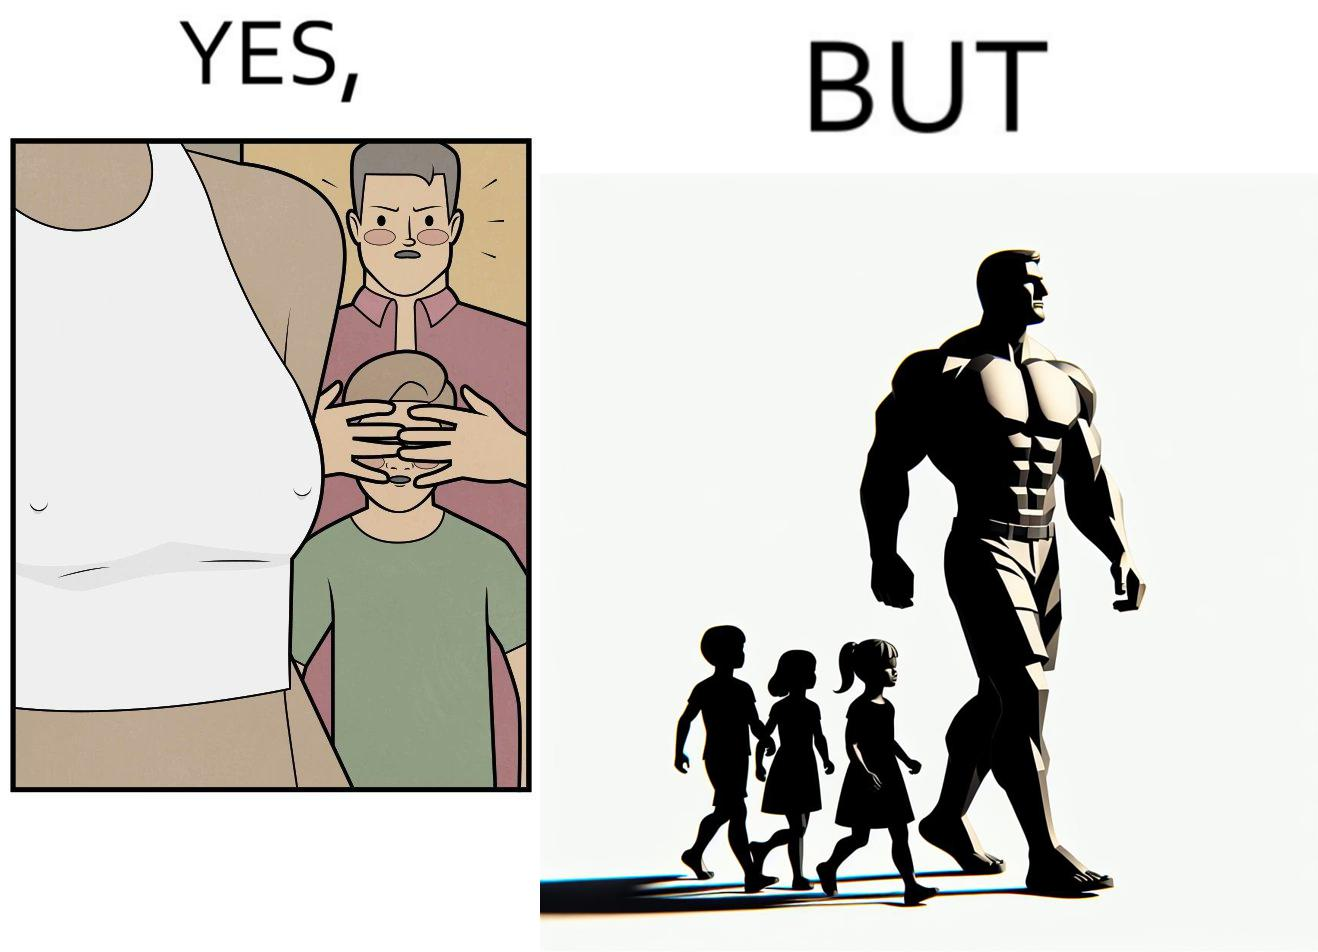What is shown in this image? Although the children is hiding his children's eyes from a women but he himself is roaming in shirt open which is showing his body. 